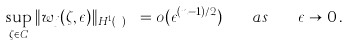<formula> <loc_0><loc_0><loc_500><loc_500>\sup _ { \zeta \in C } \| w _ { j } ( \zeta , \epsilon ) \| _ { H ^ { 1 } ( \mathbb { R } ^ { n } ) } = o ( \epsilon ^ { ( n - 1 ) / 2 } ) \quad a s \quad \epsilon \to 0 \, .</formula> 